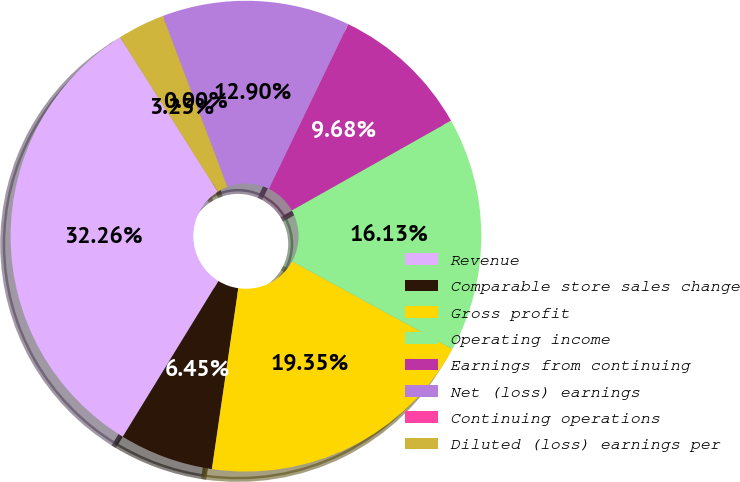Convert chart to OTSL. <chart><loc_0><loc_0><loc_500><loc_500><pie_chart><fcel>Revenue<fcel>Comparable store sales change<fcel>Gross profit<fcel>Operating income<fcel>Earnings from continuing<fcel>Net (loss) earnings<fcel>Continuing operations<fcel>Diluted (loss) earnings per<nl><fcel>32.26%<fcel>6.45%<fcel>19.35%<fcel>16.13%<fcel>9.68%<fcel>12.9%<fcel>0.0%<fcel>3.23%<nl></chart> 